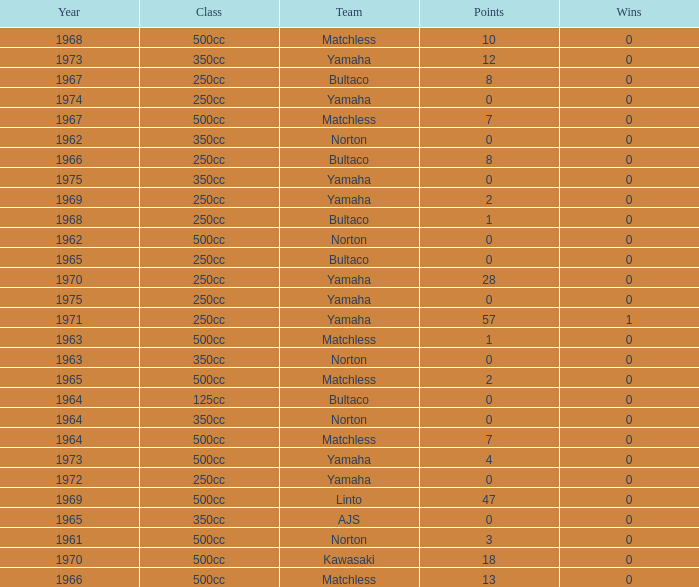Could you parse the entire table as a dict? {'header': ['Year', 'Class', 'Team', 'Points', 'Wins'], 'rows': [['1968', '500cc', 'Matchless', '10', '0'], ['1973', '350cc', 'Yamaha', '12', '0'], ['1967', '250cc', 'Bultaco', '8', '0'], ['1974', '250cc', 'Yamaha', '0', '0'], ['1967', '500cc', 'Matchless', '7', '0'], ['1962', '350cc', 'Norton', '0', '0'], ['1966', '250cc', 'Bultaco', '8', '0'], ['1975', '350cc', 'Yamaha', '0', '0'], ['1969', '250cc', 'Yamaha', '2', '0'], ['1968', '250cc', 'Bultaco', '1', '0'], ['1962', '500cc', 'Norton', '0', '0'], ['1965', '250cc', 'Bultaco', '0', '0'], ['1970', '250cc', 'Yamaha', '28', '0'], ['1975', '250cc', 'Yamaha', '0', '0'], ['1971', '250cc', 'Yamaha', '57', '1'], ['1963', '500cc', 'Matchless', '1', '0'], ['1963', '350cc', 'Norton', '0', '0'], ['1965', '500cc', 'Matchless', '2', '0'], ['1964', '125cc', 'Bultaco', '0', '0'], ['1964', '350cc', 'Norton', '0', '0'], ['1964', '500cc', 'Matchless', '7', '0'], ['1973', '500cc', 'Yamaha', '4', '0'], ['1972', '250cc', 'Yamaha', '0', '0'], ['1969', '500cc', 'Linto', '47', '0'], ['1965', '350cc', 'AJS', '0', '0'], ['1961', '500cc', 'Norton', '3', '0'], ['1970', '500cc', 'Kawasaki', '18', '0'], ['1966', '500cc', 'Matchless', '13', '0']]} What is the average wins in 250cc class for Bultaco with 8 points later than 1966? 0.0. 